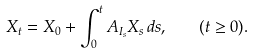<formula> <loc_0><loc_0><loc_500><loc_500>X _ { t } = X _ { 0 } + \int _ { 0 } ^ { t } A _ { I _ { s } } X _ { s } \, d s , \quad ( t \geq 0 ) .</formula> 